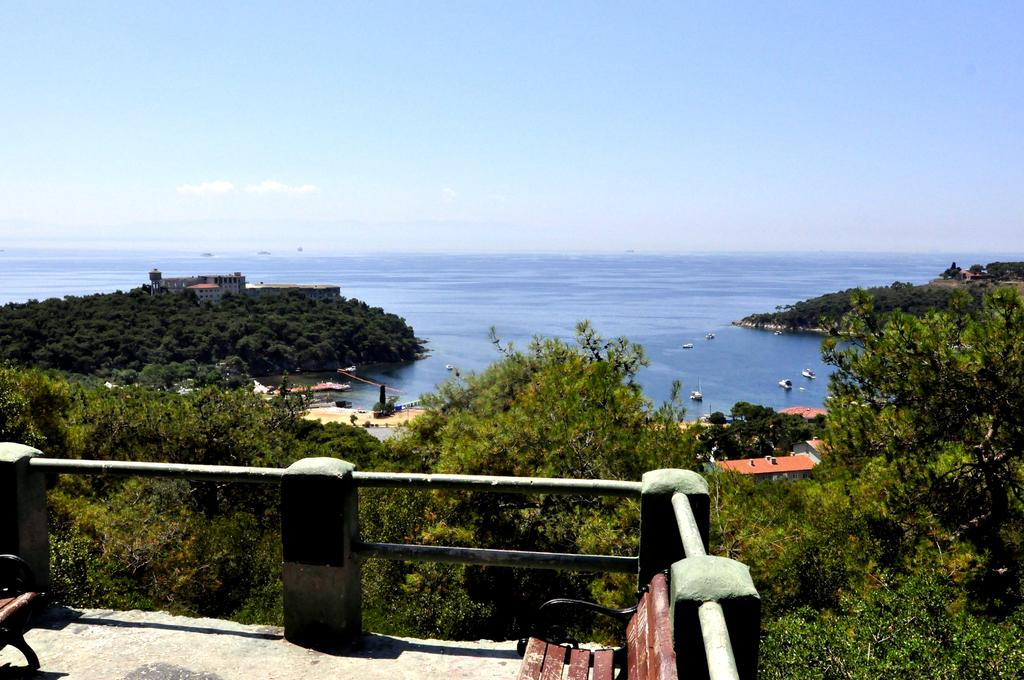What type of large body of water is visible in the image? There is an ocean in the image. What types of vehicles can be seen in the image? There are ships in the image. What type of landform is present in the image? There are hills in the image. What type of man-made structures are visible in the image? There are buildings in the image. What type of vegetation is present in the image? There are trees in the image. What part of the natural environment is visible in the image? The sky is visible in the image, and there are clouds in the sky. What type of outdoor furniture is present in the image? There are benches on the floor in the image. What type of cooking equipment is present in the image? There are grills in the image. What type of shame can be seen in the image? There is no shame present in the image; it is a scene featuring an ocean, ships, hills, buildings, trees, sky, clouds, benches, and grills. What type of feast is being prepared in the image? There is no feast being prepared in the image; it is a scene featuring an ocean, ships, hills, buildings, trees, sky, clouds, benches, and grills. 